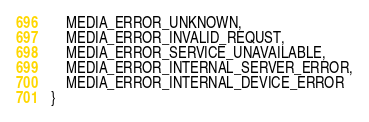<code> <loc_0><loc_0><loc_500><loc_500><_Kotlin_>    MEDIA_ERROR_UNKNOWN,
    MEDIA_ERROR_INVALID_REQUST,
    MEDIA_ERROR_SERVICE_UNAVAILABLE,
    MEDIA_ERROR_INTERNAL_SERVER_ERROR,
    MEDIA_ERROR_INTERNAL_DEVICE_ERROR
}</code> 